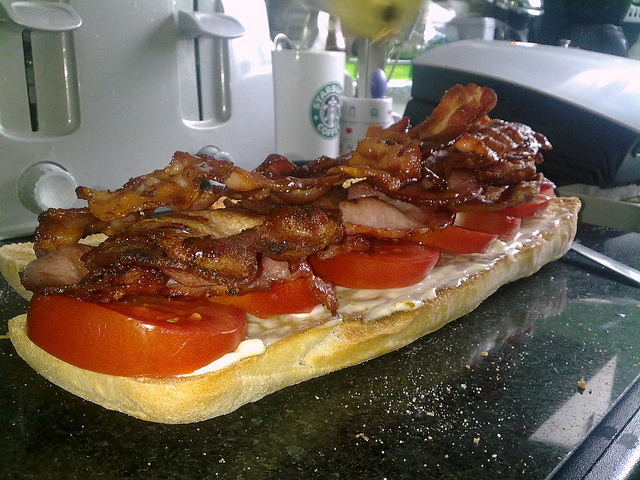What is this photo about? This photo showcases a close-up of a delicious-looking sandwich. The sandwich features a long piece of bread topped with fresh slices of tomato and a generous amount of crispy bacon. In the background, there are household kitchen items like a toaster, a cup, and some other kitchen appliances, adding context to the preparation environment. 